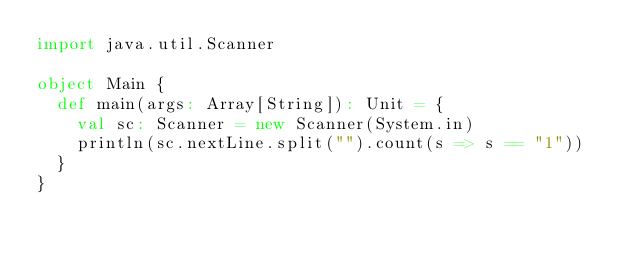<code> <loc_0><loc_0><loc_500><loc_500><_Scala_>import java.util.Scanner

object Main {
  def main(args: Array[String]): Unit = {
    val sc: Scanner = new Scanner(System.in)
    println(sc.nextLine.split("").count(s => s == "1"))
  }
}
</code> 